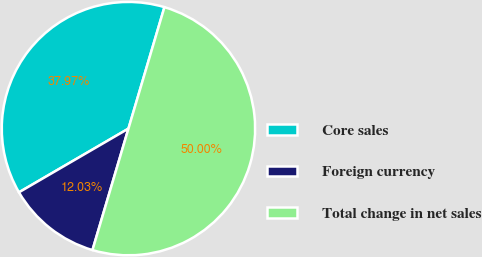<chart> <loc_0><loc_0><loc_500><loc_500><pie_chart><fcel>Core sales<fcel>Foreign currency<fcel>Total change in net sales<nl><fcel>37.97%<fcel>12.03%<fcel>50.0%<nl></chart> 